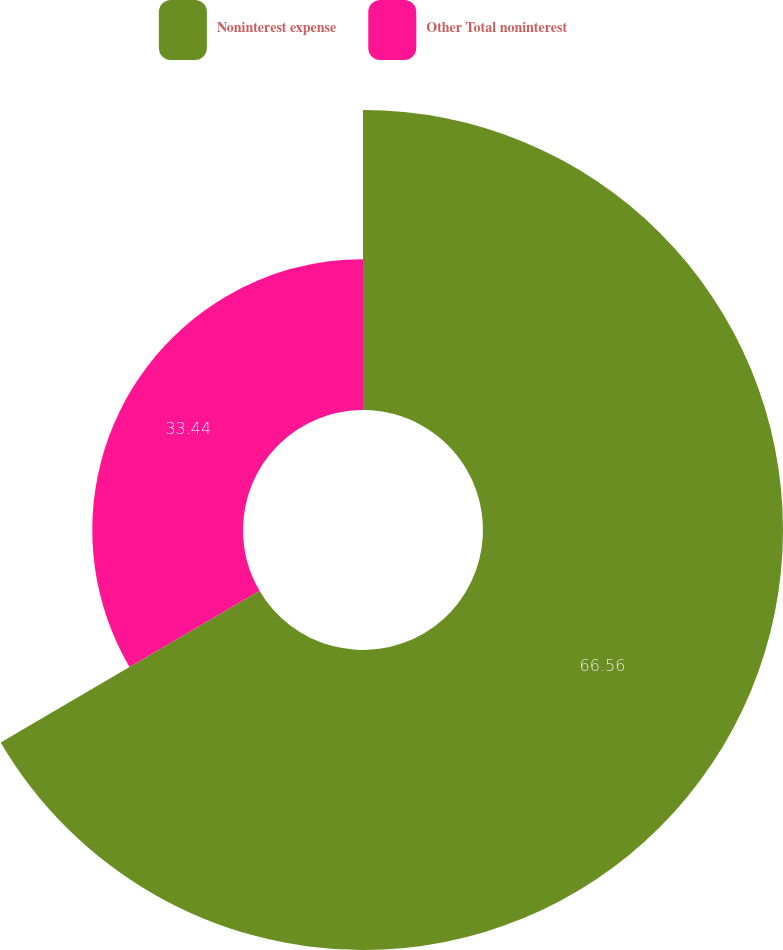Convert chart to OTSL. <chart><loc_0><loc_0><loc_500><loc_500><pie_chart><fcel>Noninterest expense<fcel>Other Total noninterest<nl><fcel>66.56%<fcel>33.44%<nl></chart> 